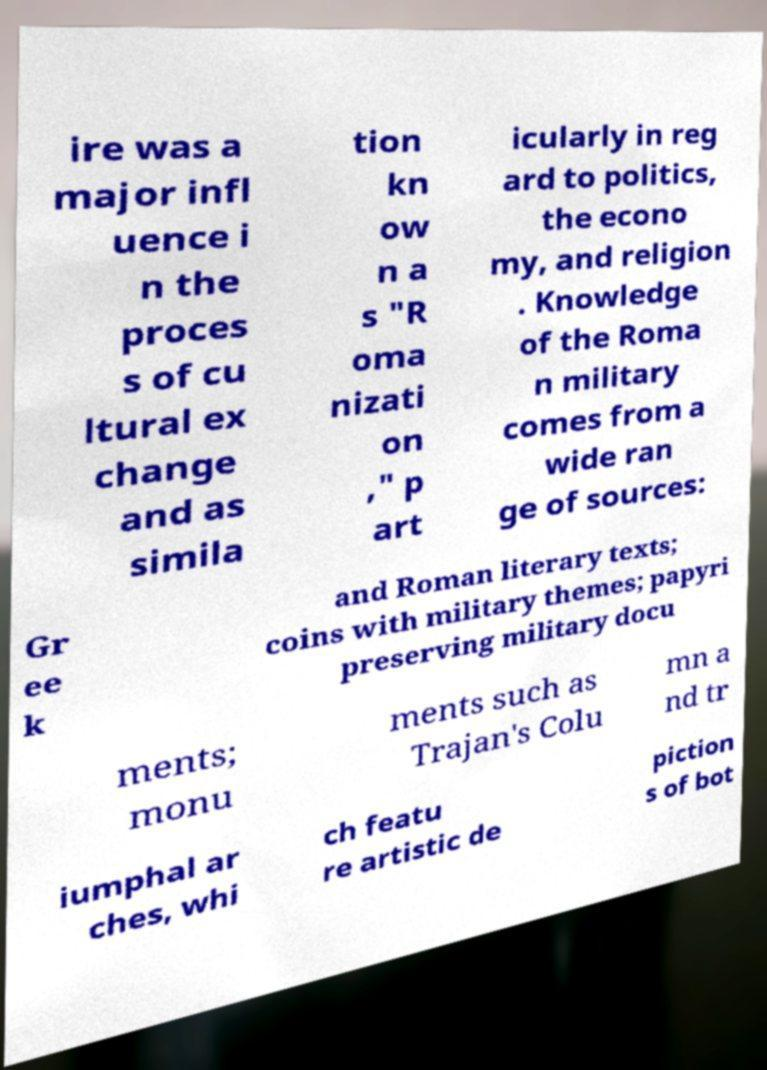There's text embedded in this image that I need extracted. Can you transcribe it verbatim? ire was a major infl uence i n the proces s of cu ltural ex change and as simila tion kn ow n a s "R oma nizati on ," p art icularly in reg ard to politics, the econo my, and religion . Knowledge of the Roma n military comes from a wide ran ge of sources: Gr ee k and Roman literary texts; coins with military themes; papyri preserving military docu ments; monu ments such as Trajan's Colu mn a nd tr iumphal ar ches, whi ch featu re artistic de piction s of bot 